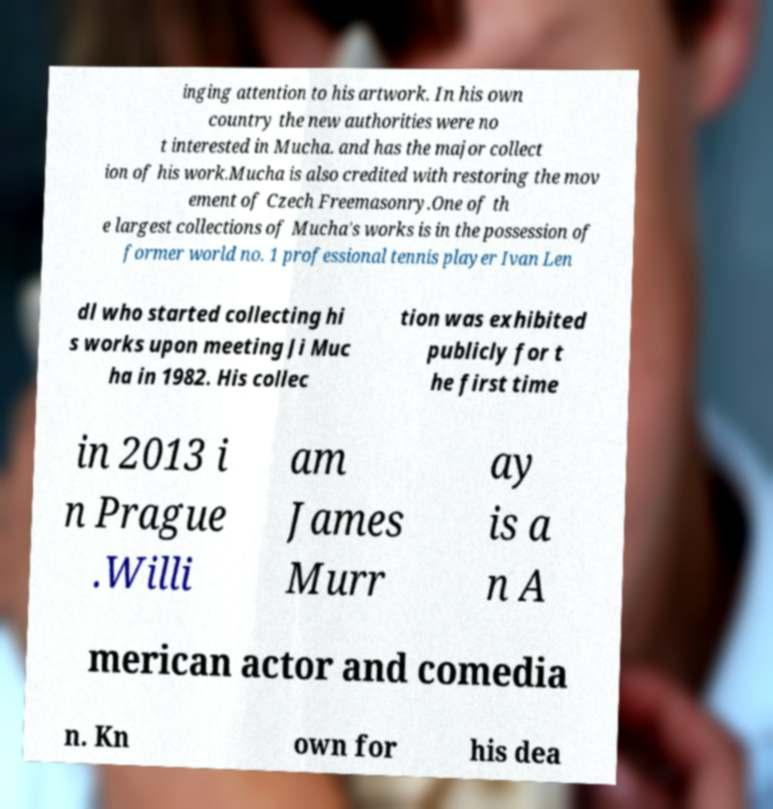What messages or text are displayed in this image? I need them in a readable, typed format. inging attention to his artwork. In his own country the new authorities were no t interested in Mucha. and has the major collect ion of his work.Mucha is also credited with restoring the mov ement of Czech Freemasonry.One of th e largest collections of Mucha's works is in the possession of former world no. 1 professional tennis player Ivan Len dl who started collecting hi s works upon meeting Ji Muc ha in 1982. His collec tion was exhibited publicly for t he first time in 2013 i n Prague .Willi am James Murr ay is a n A merican actor and comedia n. Kn own for his dea 